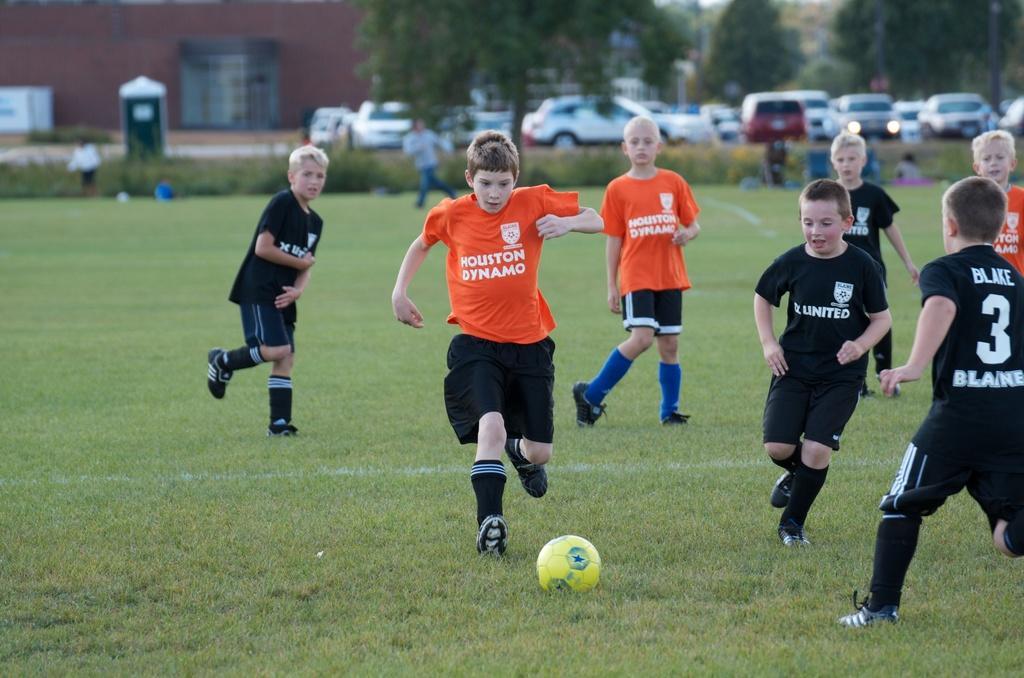Please provide a concise description of this image. In this image we can see there are so many people playing football in the ground, behind that there are cars parked in the road, also there are trees and buildings behind the road. 